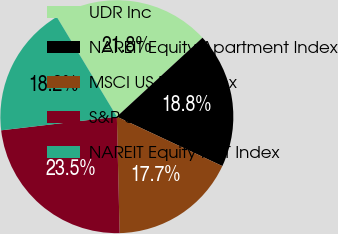Convert chart to OTSL. <chart><loc_0><loc_0><loc_500><loc_500><pie_chart><fcel>UDR Inc<fcel>NAREIT Equity Apartment Index<fcel>MSCI US REIT Index<fcel>S&P 500 Index<fcel>NAREIT Equity REIT Index<nl><fcel>21.77%<fcel>18.82%<fcel>17.65%<fcel>23.51%<fcel>18.24%<nl></chart> 